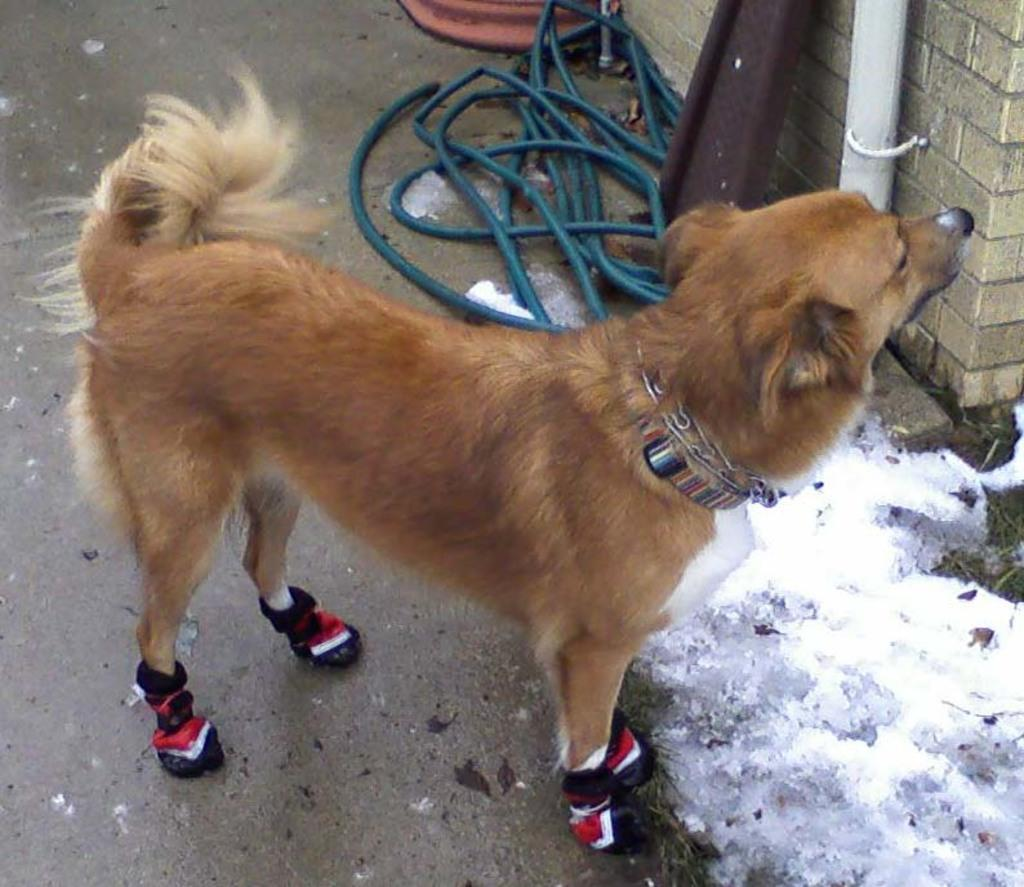What type of animal can be seen in the image? There is a dog in the image. What is the background of the image? There is a wall in the image. What other objects are present in the image? There is a pipe and other materials, including a rod, in the image. What type of cloud can be seen in the image? There are no clouds present in the image. 